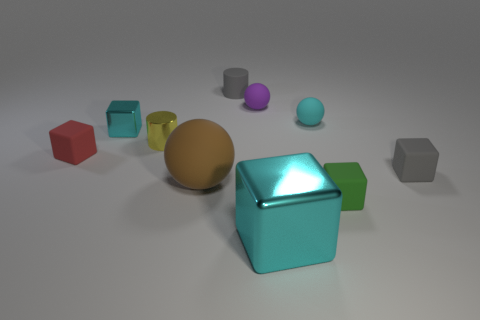There is a small rubber object that is the same color as the big metal cube; what shape is it?
Keep it short and to the point. Sphere. Are there any yellow shiny things left of the red rubber block?
Provide a short and direct response. No. Do the red matte thing and the brown thing have the same shape?
Your answer should be compact. No. How big is the sphere behind the cyan matte object that is on the right side of the cyan block that is in front of the tiny red block?
Give a very brief answer. Small. What is the red block made of?
Offer a terse response. Rubber. What size is the other cube that is the same color as the large metal block?
Offer a terse response. Small. There is a cyan matte object; is its shape the same as the large thing that is on the right side of the large brown thing?
Your answer should be compact. No. There is a tiny gray object behind the small matte ball on the left side of the cyan shiny cube that is to the right of the small cyan cube; what is its material?
Provide a short and direct response. Rubber. What number of yellow cylinders are there?
Your answer should be compact. 1. What number of blue things are tiny metallic cylinders or tiny cubes?
Ensure brevity in your answer.  0. 